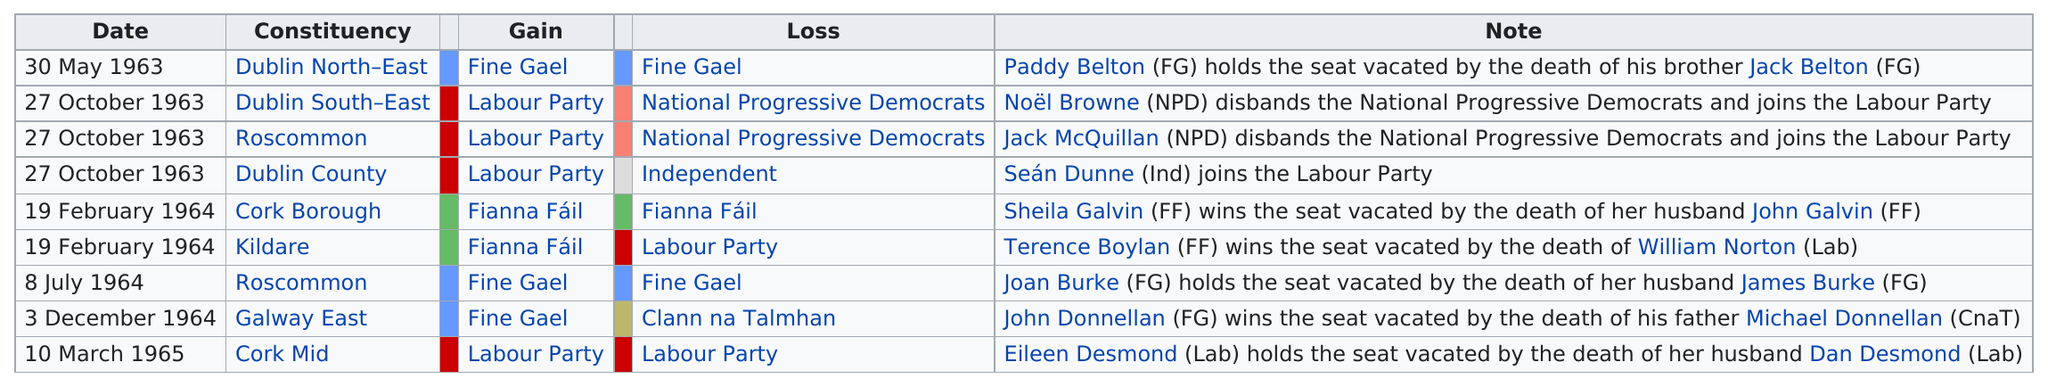Draw attention to some important aspects in this diagram. The Labour Party had a seat taken by Sean Dunne. John Donnellan held the seat after the death of his father. The person who holds the seat vacated by the death of his brother is Paddy Belton. Fine Gael is listed for gain three times. There are 9 dates listed. 